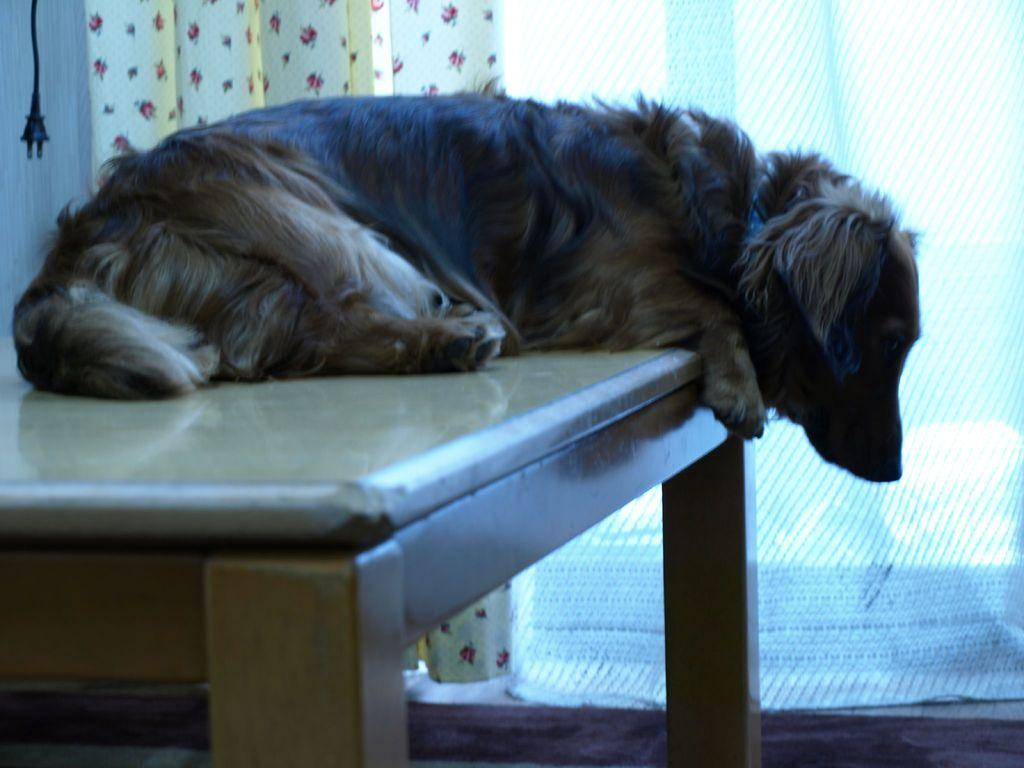What animal is present in the image? There is a dog in the image. Where is the dog located? The dog is sitting on a bench. What can be seen in the background of the image? There is a curtain and a black plug hanging in the background of the image. How many trees are visible in the image? There are no trees visible in the image. 